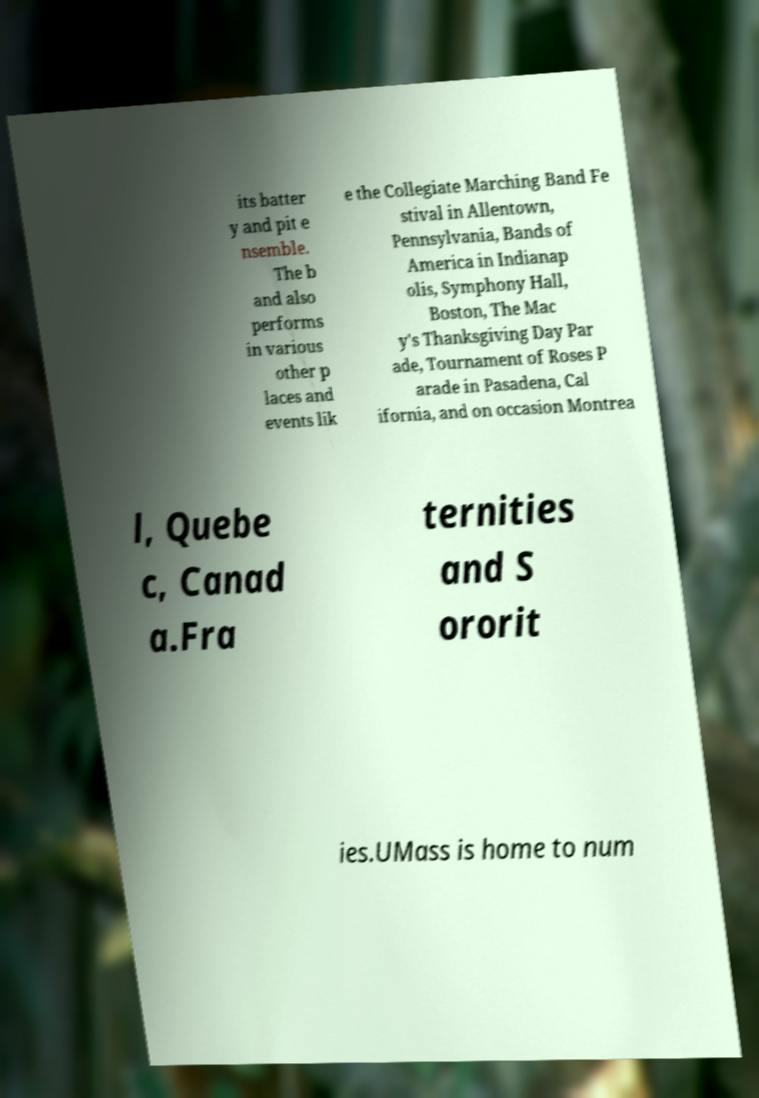There's text embedded in this image that I need extracted. Can you transcribe it verbatim? its batter y and pit e nsemble. The b and also performs in various other p laces and events lik e the Collegiate Marching Band Fe stival in Allentown, Pennsylvania, Bands of America in Indianap olis, Symphony Hall, Boston, The Mac y's Thanksgiving Day Par ade, Tournament of Roses P arade in Pasadena, Cal ifornia, and on occasion Montrea l, Quebe c, Canad a.Fra ternities and S ororit ies.UMass is home to num 